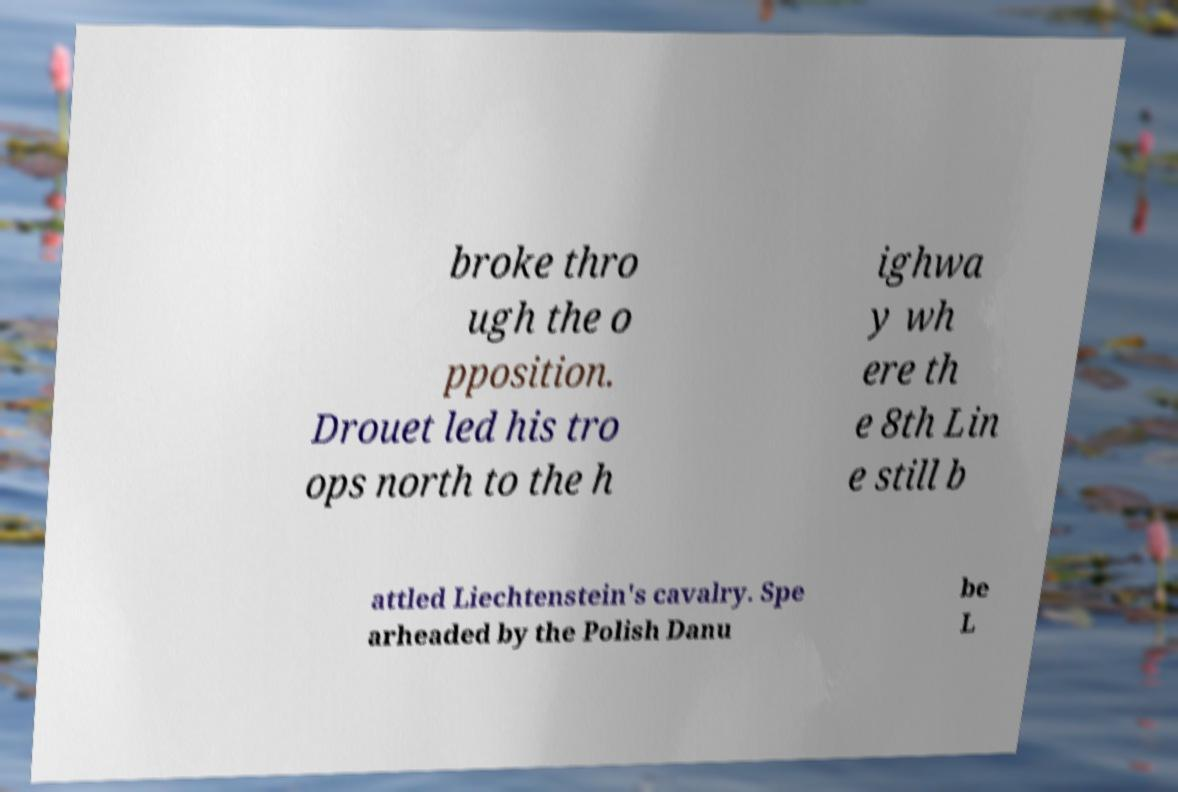Can you read and provide the text displayed in the image?This photo seems to have some interesting text. Can you extract and type it out for me? broke thro ugh the o pposition. Drouet led his tro ops north to the h ighwa y wh ere th e 8th Lin e still b attled Liechtenstein's cavalry. Spe arheaded by the Polish Danu be L 